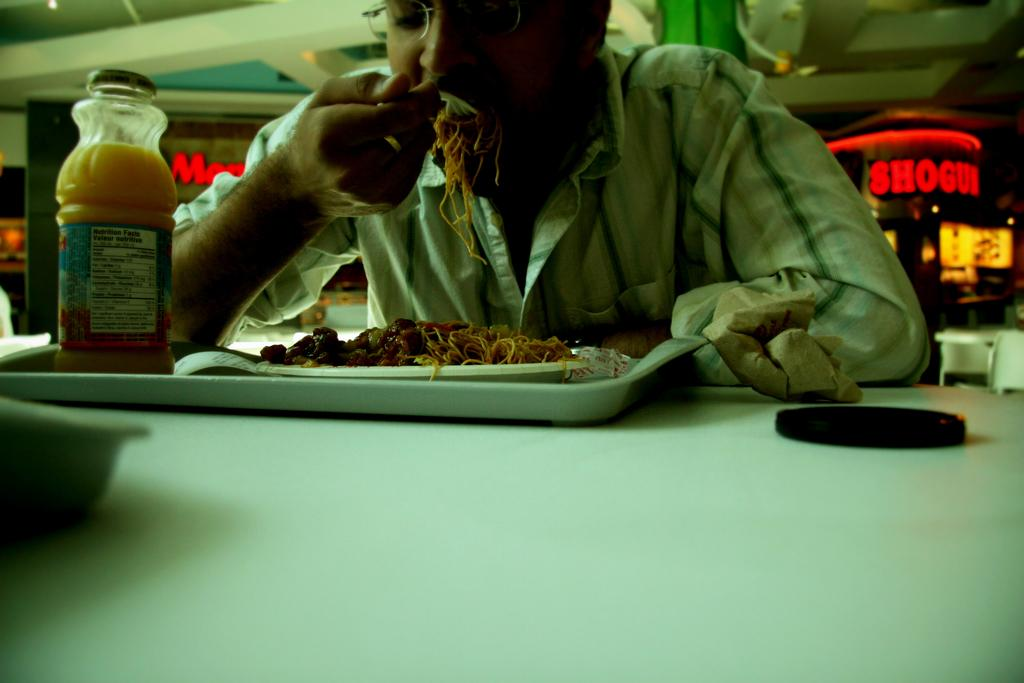<image>
Write a terse but informative summary of the picture. A man is eating in a cafeteria in front of a red sign saying shogun. 